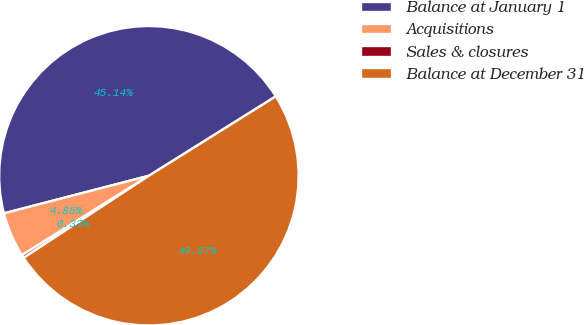Convert chart to OTSL. <chart><loc_0><loc_0><loc_500><loc_500><pie_chart><fcel>Balance at January 1<fcel>Acquisitions<fcel>Sales & closures<fcel>Balance at December 31<nl><fcel>45.14%<fcel>4.86%<fcel>0.33%<fcel>49.67%<nl></chart> 